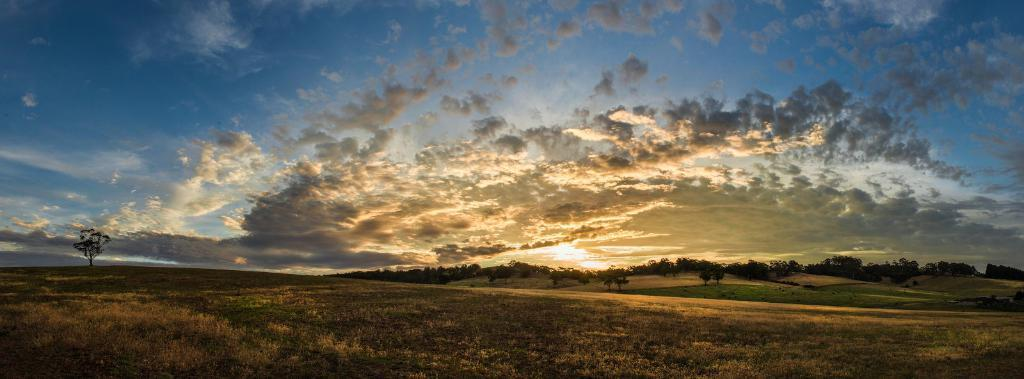What type of vegetation can be seen in the image? There are trees in the image. What is the ground covered with in the image? There is dry grass in the image. What part of the natural environment is visible in the image? The sky is visible in the image. What can be seen in the sky in the image? Clouds are present in the sky. Where are the trousers hanging in the image? There are no trousers present in the image. What does the mom say about the weather in the image? There is no mom present in the image, and therefore no comment about the weather can be attributed to her. 